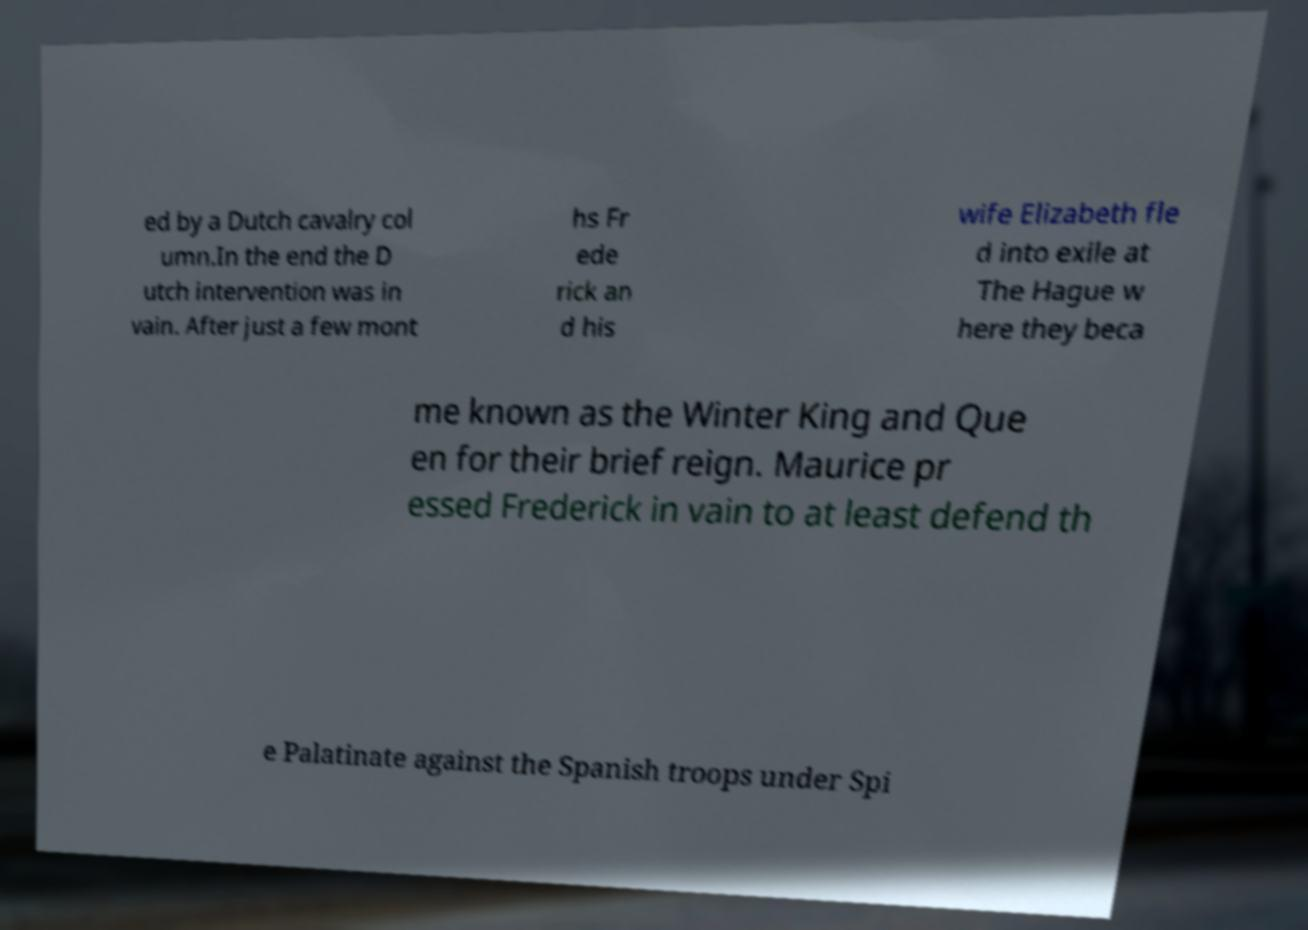Could you extract and type out the text from this image? ed by a Dutch cavalry col umn.In the end the D utch intervention was in vain. After just a few mont hs Fr ede rick an d his wife Elizabeth fle d into exile at The Hague w here they beca me known as the Winter King and Que en for their brief reign. Maurice pr essed Frederick in vain to at least defend th e Palatinate against the Spanish troops under Spi 